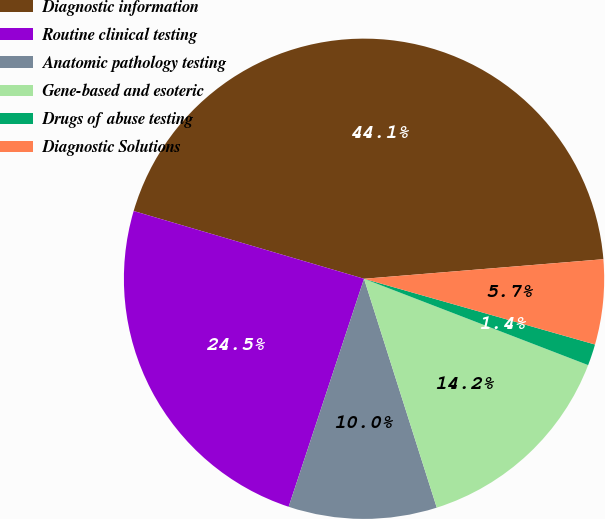<chart> <loc_0><loc_0><loc_500><loc_500><pie_chart><fcel>Diagnostic information<fcel>Routine clinical testing<fcel>Anatomic pathology testing<fcel>Gene-based and esoteric<fcel>Drugs of abuse testing<fcel>Diagnostic Solutions<nl><fcel>44.15%<fcel>24.47%<fcel>9.98%<fcel>14.25%<fcel>1.44%<fcel>5.71%<nl></chart> 